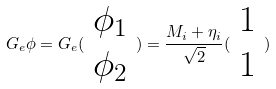Convert formula to latex. <formula><loc_0><loc_0><loc_500><loc_500>G _ { e } \phi = G _ { e } ( \begin{array} { c } \phi _ { 1 } \\ \phi _ { 2 } \end{array} ) = \frac { M _ { i } + \eta _ { i } } { \sqrt { 2 } } ( \begin{array} { c } 1 \\ 1 \end{array} )</formula> 